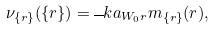Convert formula to latex. <formula><loc_0><loc_0><loc_500><loc_500>\nu _ { \{ r \} } ( \{ r \} ) = { \overline { \ } k a } _ { W _ { 0 } r } m _ { \{ r \} } ( r ) ,</formula> 